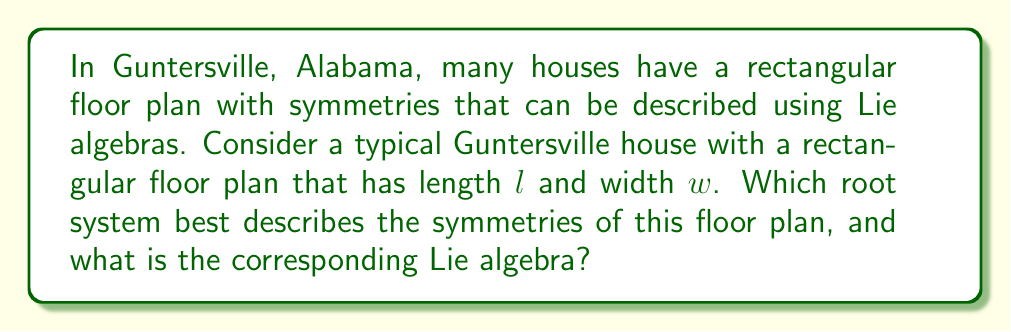What is the answer to this math problem? To answer this question, let's approach it step-by-step:

1) First, we need to consider the symmetries of a rectangular floor plan:
   - Rotation by 180 degrees (or π radians) around the center
   - Reflection across the length axis
   - Reflection across the width axis
   - Identity transformation (no change)

2) These symmetries form a group isomorphic to the Klein four-group, also known as $\mathbb{Z}_2 \times \mathbb{Z}_2$.

3) The Lie algebra that corresponds to this group of symmetries is $\mathfrak{so}(2) \oplus \mathfrak{so}(2)$, where $\mathfrak{so}(2)$ is the special orthogonal Lie algebra in 2 dimensions.

4) The root system of $\mathfrak{so}(2) \oplus \mathfrak{so}(2)$ consists of four roots in a 2-dimensional space:
   $$\{\pm e_1, \pm e_2\}$$
   where $e_1$ and $e_2$ are the standard basis vectors.

5) This root system is known as $A_1 \times A_1$, where $A_1$ is the root system of $\mathfrak{sl}(2, \mathbb{C})$ or $\mathfrak{so}(3)$.

6) The Dynkin diagram for this root system consists of two disconnected nodes:

   [asy]
   unitsize(1cm);
   dot((0,0)); dot((1,0));
   label("$\alpha_1$", (0,-0.3));
   label("$\alpha_2$", (1,-0.3));
   [/asy]

7) The corresponding Lie algebra is often denoted as $A_1 \oplus A_1$.
Answer: The root system that best describes the symmetries of a typical rectangular Guntersville house floor plan is $A_1 \times A_1$, and the corresponding Lie algebra is $A_1 \oplus A_1$ or $\mathfrak{so}(2) \oplus \mathfrak{so}(2)$. 